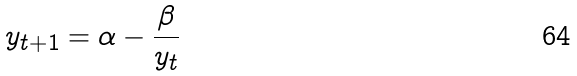<formula> <loc_0><loc_0><loc_500><loc_500>y _ { t + 1 } = \alpha - \frac { \beta } { y _ { t } }</formula> 